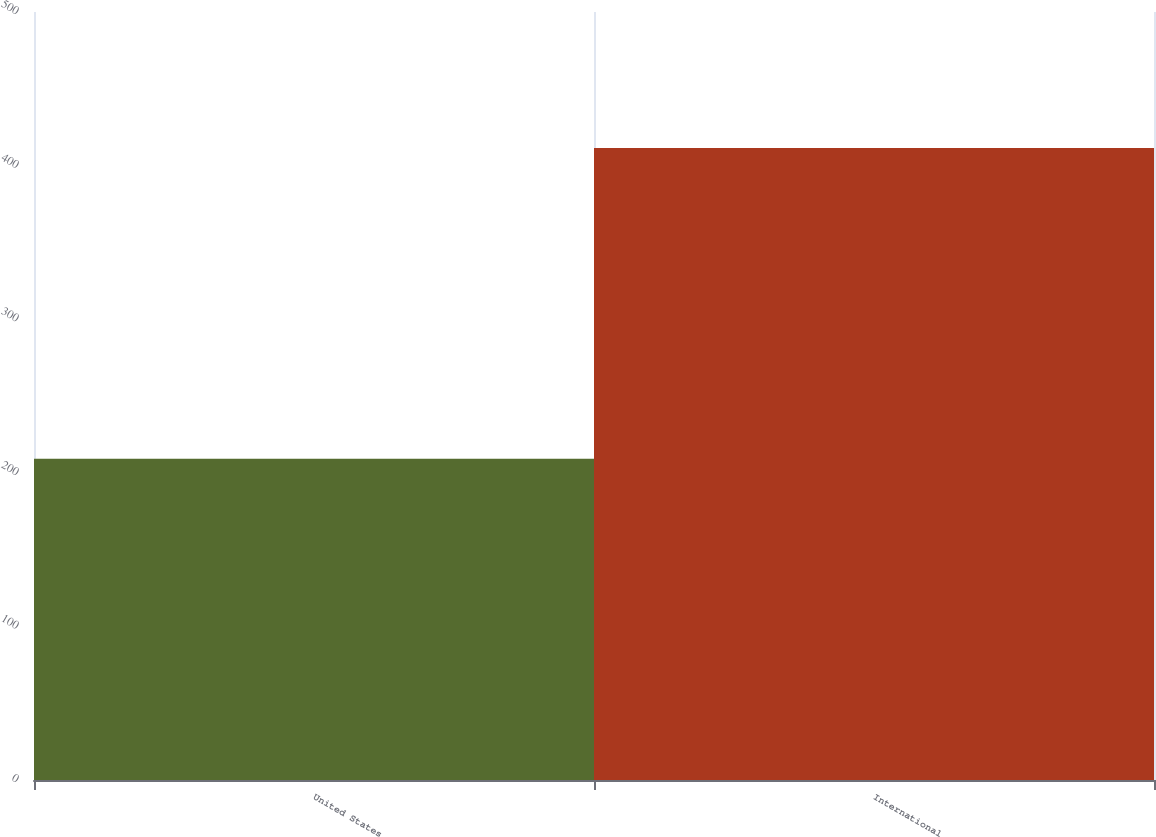Convert chart. <chart><loc_0><loc_0><loc_500><loc_500><bar_chart><fcel>United States<fcel>International<nl><fcel>209.2<fcel>411.4<nl></chart> 